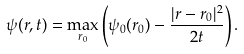Convert formula to latex. <formula><loc_0><loc_0><loc_500><loc_500>\psi ( { r } , t ) = \max _ { { r } _ { 0 } } \left ( \psi _ { 0 } ( { r } _ { 0 } ) - \frac { | { r } - { r } _ { 0 } | ^ { 2 } } { 2 t } \right ) .</formula> 